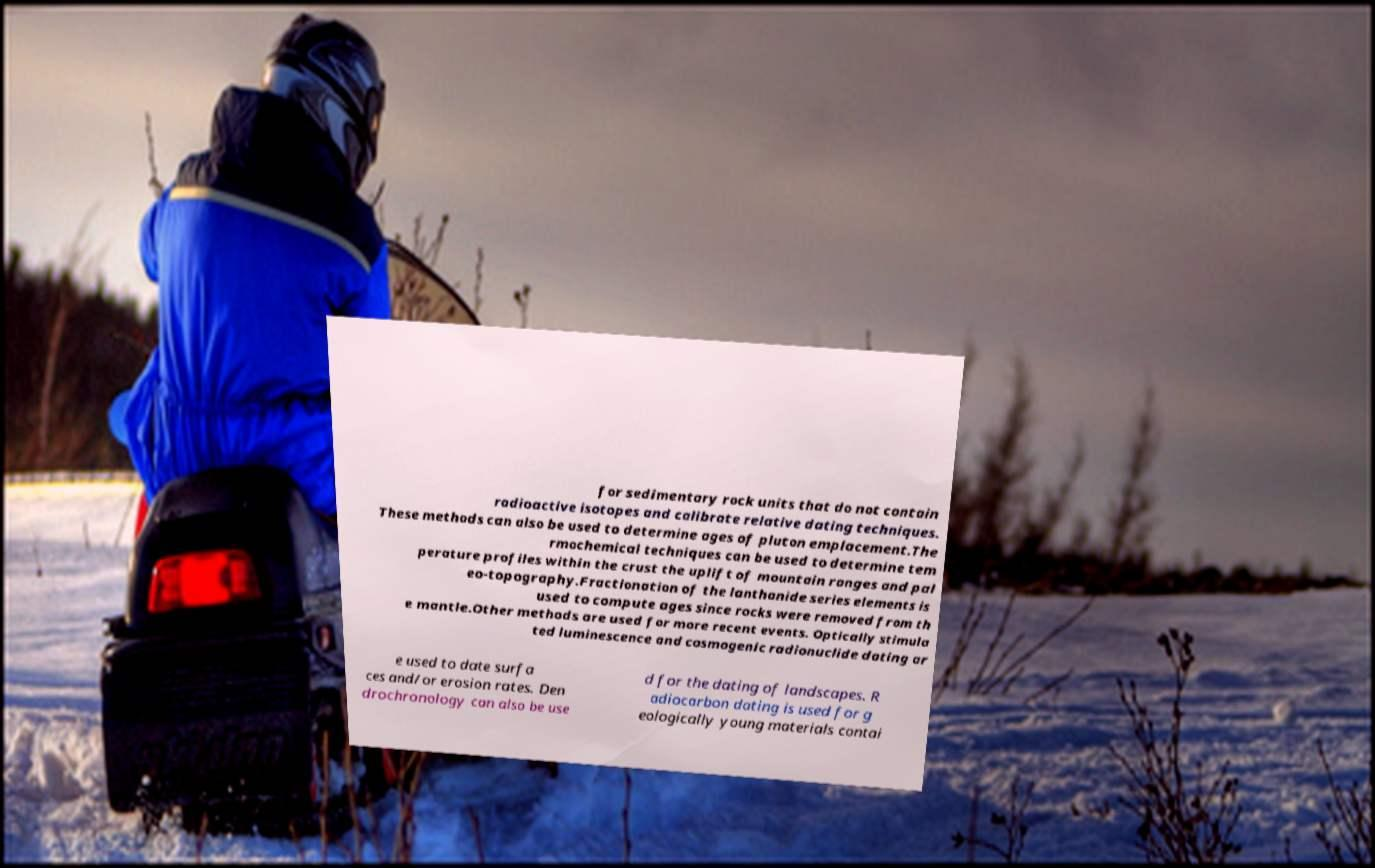I need the written content from this picture converted into text. Can you do that? for sedimentary rock units that do not contain radioactive isotopes and calibrate relative dating techniques. These methods can also be used to determine ages of pluton emplacement.The rmochemical techniques can be used to determine tem perature profiles within the crust the uplift of mountain ranges and pal eo-topography.Fractionation of the lanthanide series elements is used to compute ages since rocks were removed from th e mantle.Other methods are used for more recent events. Optically stimula ted luminescence and cosmogenic radionuclide dating ar e used to date surfa ces and/or erosion rates. Den drochronology can also be use d for the dating of landscapes. R adiocarbon dating is used for g eologically young materials contai 